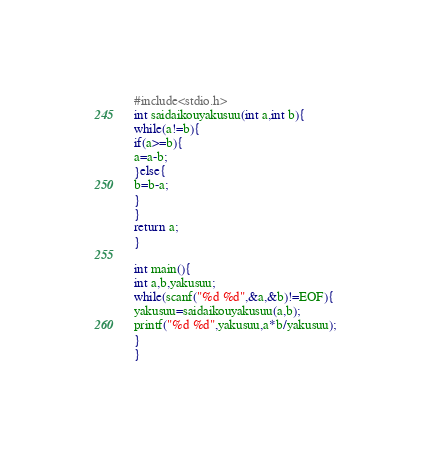Convert code to text. <code><loc_0><loc_0><loc_500><loc_500><_C_>#include<stdio.h>
int saidaikouyakusuu(int a,int b){
while(a!=b){
if(a>=b){
a=a-b;
}else{
b=b-a;
}
}
return a;
}

int main(){
int a,b,yakusuu;
while(scanf("%d %d",&a,&b)!=EOF){
yakusuu=saidaikouyakusuu(a,b);
printf("%d %d",yakusuu,a*b/yakusuu);
}
}</code> 